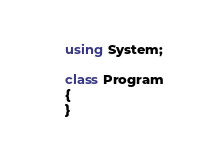<code> <loc_0><loc_0><loc_500><loc_500><_C#_>using System;

class Program
{
}
</code> 